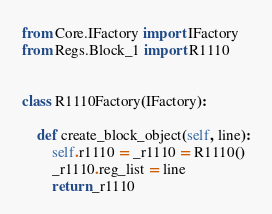<code> <loc_0><loc_0><loc_500><loc_500><_Python_>from Core.IFactory import IFactory
from Regs.Block_1 import R1110


class R1110Factory(IFactory):

    def create_block_object(self, line):
        self.r1110 = _r1110 = R1110()
        _r1110.reg_list = line
        return _r1110
</code> 